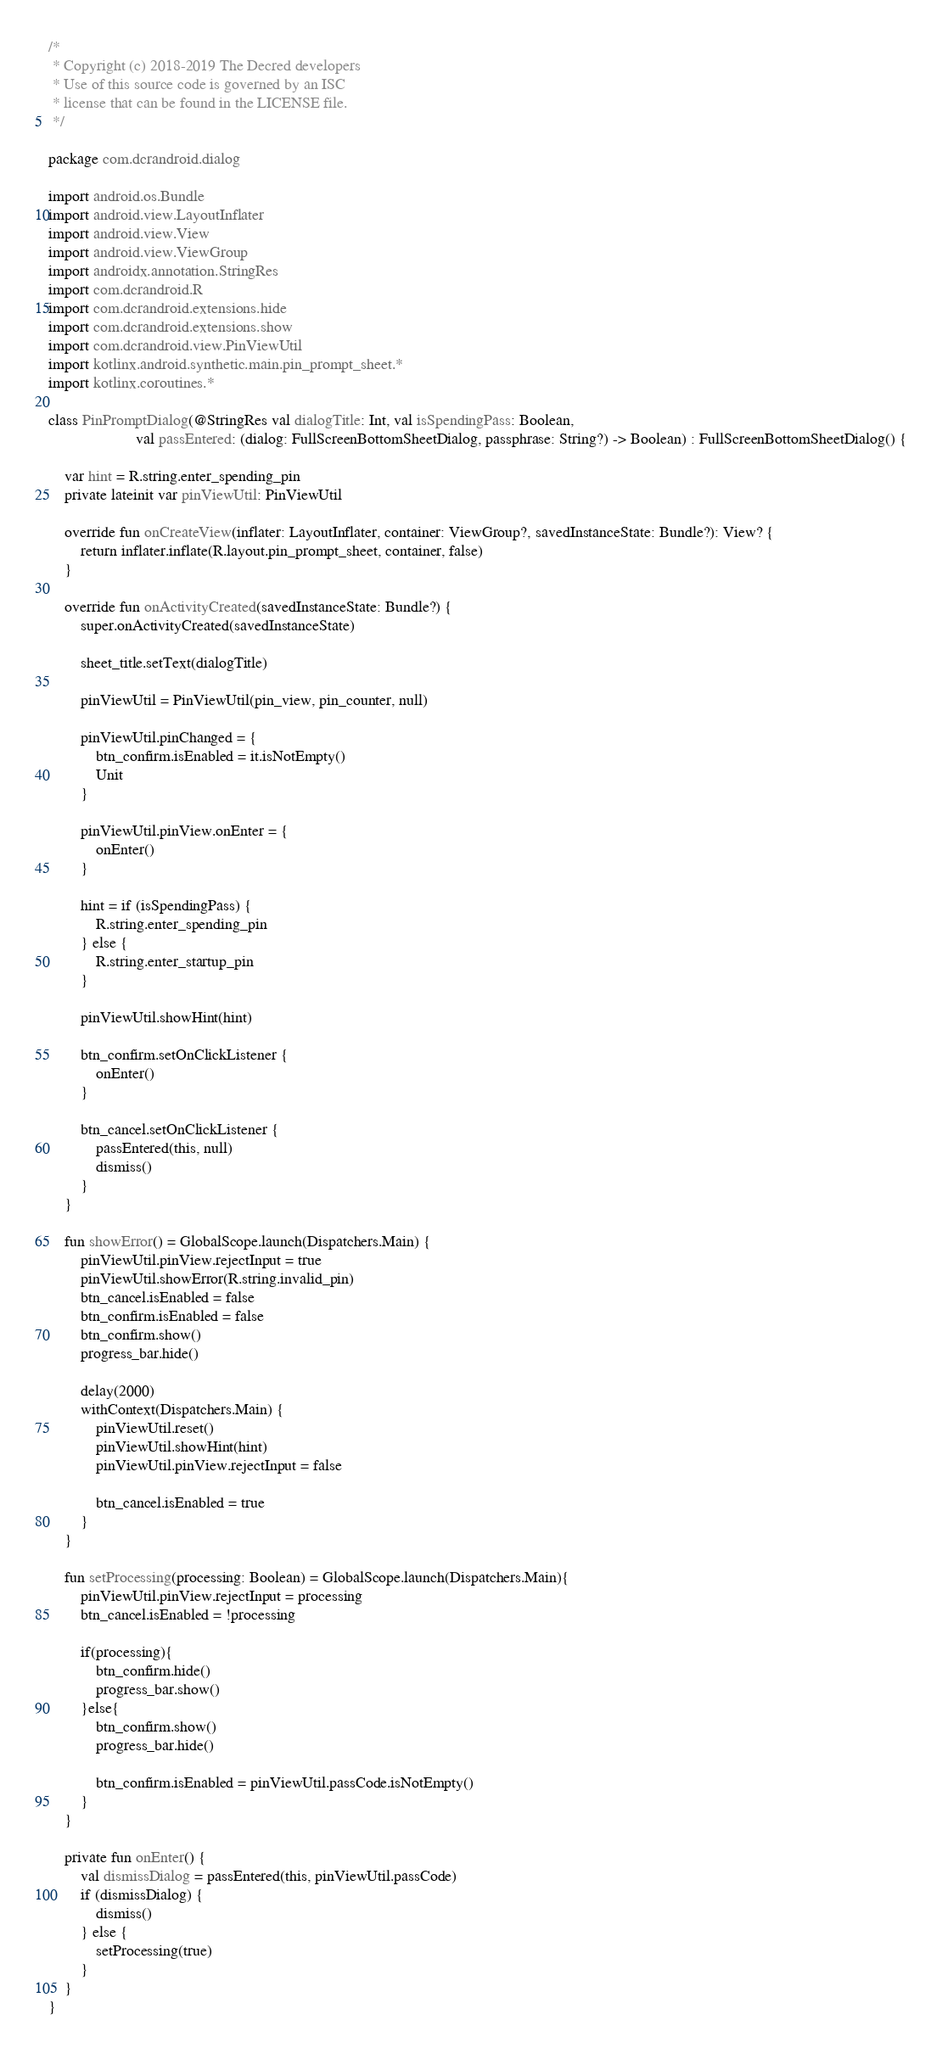Convert code to text. <code><loc_0><loc_0><loc_500><loc_500><_Kotlin_>/*
 * Copyright (c) 2018-2019 The Decred developers
 * Use of this source code is governed by an ISC
 * license that can be found in the LICENSE file.
 */

package com.dcrandroid.dialog

import android.os.Bundle
import android.view.LayoutInflater
import android.view.View
import android.view.ViewGroup
import androidx.annotation.StringRes
import com.dcrandroid.R
import com.dcrandroid.extensions.hide
import com.dcrandroid.extensions.show
import com.dcrandroid.view.PinViewUtil
import kotlinx.android.synthetic.main.pin_prompt_sheet.*
import kotlinx.coroutines.*

class PinPromptDialog(@StringRes val dialogTitle: Int, val isSpendingPass: Boolean,
                      val passEntered: (dialog: FullScreenBottomSheetDialog, passphrase: String?) -> Boolean) : FullScreenBottomSheetDialog() {

    var hint = R.string.enter_spending_pin
    private lateinit var pinViewUtil: PinViewUtil

    override fun onCreateView(inflater: LayoutInflater, container: ViewGroup?, savedInstanceState: Bundle?): View? {
        return inflater.inflate(R.layout.pin_prompt_sheet, container, false)
    }

    override fun onActivityCreated(savedInstanceState: Bundle?) {
        super.onActivityCreated(savedInstanceState)

        sheet_title.setText(dialogTitle)

        pinViewUtil = PinViewUtil(pin_view, pin_counter, null)

        pinViewUtil.pinChanged = {
            btn_confirm.isEnabled = it.isNotEmpty()
            Unit
        }

        pinViewUtil.pinView.onEnter = {
            onEnter()
        }

        hint = if (isSpendingPass) {
            R.string.enter_spending_pin
        } else {
            R.string.enter_startup_pin
        }

        pinViewUtil.showHint(hint)

        btn_confirm.setOnClickListener {
            onEnter()
        }

        btn_cancel.setOnClickListener {
            passEntered(this, null)
            dismiss()
        }
    }

    fun showError() = GlobalScope.launch(Dispatchers.Main) {
        pinViewUtil.pinView.rejectInput = true
        pinViewUtil.showError(R.string.invalid_pin)
        btn_cancel.isEnabled = false
        btn_confirm.isEnabled = false
        btn_confirm.show()
        progress_bar.hide()

        delay(2000)
        withContext(Dispatchers.Main) {
            pinViewUtil.reset()
            pinViewUtil.showHint(hint)
            pinViewUtil.pinView.rejectInput = false

            btn_cancel.isEnabled = true
        }
    }

    fun setProcessing(processing: Boolean) = GlobalScope.launch(Dispatchers.Main){
        pinViewUtil.pinView.rejectInput = processing
        btn_cancel.isEnabled = !processing

        if(processing){
            btn_confirm.hide()
            progress_bar.show()
        }else{
            btn_confirm.show()
            progress_bar.hide()

            btn_confirm.isEnabled = pinViewUtil.passCode.isNotEmpty()
        }
    }

    private fun onEnter() {
        val dismissDialog = passEntered(this, pinViewUtil.passCode)
        if (dismissDialog) {
            dismiss()
        } else {
            setProcessing(true)
        }
    }
}</code> 